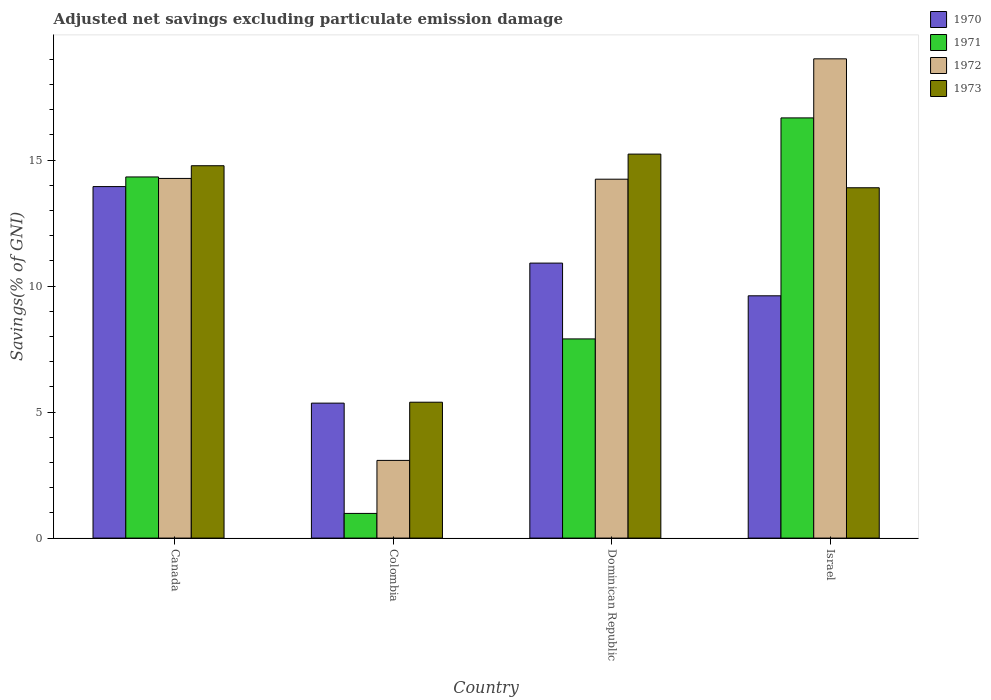What is the adjusted net savings in 1970 in Dominican Republic?
Your response must be concise. 10.91. Across all countries, what is the maximum adjusted net savings in 1973?
Provide a succinct answer. 15.24. Across all countries, what is the minimum adjusted net savings in 1973?
Your answer should be very brief. 5.39. In which country was the adjusted net savings in 1973 minimum?
Offer a terse response. Colombia. What is the total adjusted net savings in 1973 in the graph?
Offer a terse response. 49.31. What is the difference between the adjusted net savings in 1973 in Canada and that in Dominican Republic?
Make the answer very short. -0.46. What is the difference between the adjusted net savings in 1972 in Israel and the adjusted net savings in 1971 in Dominican Republic?
Keep it short and to the point. 11.11. What is the average adjusted net savings in 1970 per country?
Offer a terse response. 9.96. What is the difference between the adjusted net savings of/in 1973 and adjusted net savings of/in 1972 in Colombia?
Ensure brevity in your answer.  2.31. What is the ratio of the adjusted net savings in 1971 in Dominican Republic to that in Israel?
Your response must be concise. 0.47. Is the adjusted net savings in 1970 in Canada less than that in Dominican Republic?
Keep it short and to the point. No. What is the difference between the highest and the second highest adjusted net savings in 1971?
Keep it short and to the point. 2.34. What is the difference between the highest and the lowest adjusted net savings in 1970?
Provide a short and direct response. 8.59. Is it the case that in every country, the sum of the adjusted net savings in 1973 and adjusted net savings in 1972 is greater than the adjusted net savings in 1971?
Offer a terse response. Yes. How many bars are there?
Offer a terse response. 16. Are all the bars in the graph horizontal?
Make the answer very short. No. How many countries are there in the graph?
Offer a terse response. 4. Are the values on the major ticks of Y-axis written in scientific E-notation?
Offer a very short reply. No. Where does the legend appear in the graph?
Provide a succinct answer. Top right. How are the legend labels stacked?
Your response must be concise. Vertical. What is the title of the graph?
Your response must be concise. Adjusted net savings excluding particulate emission damage. What is the label or title of the Y-axis?
Your answer should be very brief. Savings(% of GNI). What is the Savings(% of GNI) in 1970 in Canada?
Give a very brief answer. 13.95. What is the Savings(% of GNI) in 1971 in Canada?
Your answer should be compact. 14.33. What is the Savings(% of GNI) of 1972 in Canada?
Your answer should be compact. 14.27. What is the Savings(% of GNI) in 1973 in Canada?
Offer a very short reply. 14.78. What is the Savings(% of GNI) of 1970 in Colombia?
Ensure brevity in your answer.  5.36. What is the Savings(% of GNI) of 1971 in Colombia?
Give a very brief answer. 0.98. What is the Savings(% of GNI) in 1972 in Colombia?
Offer a terse response. 3.08. What is the Savings(% of GNI) in 1973 in Colombia?
Offer a very short reply. 5.39. What is the Savings(% of GNI) of 1970 in Dominican Republic?
Your answer should be very brief. 10.91. What is the Savings(% of GNI) of 1971 in Dominican Republic?
Make the answer very short. 7.9. What is the Savings(% of GNI) of 1972 in Dominican Republic?
Your answer should be compact. 14.24. What is the Savings(% of GNI) of 1973 in Dominican Republic?
Your response must be concise. 15.24. What is the Savings(% of GNI) in 1970 in Israel?
Offer a very short reply. 9.61. What is the Savings(% of GNI) in 1971 in Israel?
Offer a terse response. 16.67. What is the Savings(% of GNI) of 1972 in Israel?
Offer a very short reply. 19.02. What is the Savings(% of GNI) of 1973 in Israel?
Your answer should be very brief. 13.9. Across all countries, what is the maximum Savings(% of GNI) of 1970?
Keep it short and to the point. 13.95. Across all countries, what is the maximum Savings(% of GNI) of 1971?
Offer a terse response. 16.67. Across all countries, what is the maximum Savings(% of GNI) of 1972?
Give a very brief answer. 19.02. Across all countries, what is the maximum Savings(% of GNI) of 1973?
Your answer should be compact. 15.24. Across all countries, what is the minimum Savings(% of GNI) in 1970?
Make the answer very short. 5.36. Across all countries, what is the minimum Savings(% of GNI) of 1971?
Offer a terse response. 0.98. Across all countries, what is the minimum Savings(% of GNI) of 1972?
Provide a short and direct response. 3.08. Across all countries, what is the minimum Savings(% of GNI) of 1973?
Give a very brief answer. 5.39. What is the total Savings(% of GNI) of 1970 in the graph?
Make the answer very short. 39.83. What is the total Savings(% of GNI) in 1971 in the graph?
Ensure brevity in your answer.  39.89. What is the total Savings(% of GNI) in 1972 in the graph?
Give a very brief answer. 50.62. What is the total Savings(% of GNI) of 1973 in the graph?
Offer a terse response. 49.31. What is the difference between the Savings(% of GNI) of 1970 in Canada and that in Colombia?
Offer a very short reply. 8.59. What is the difference between the Savings(% of GNI) of 1971 in Canada and that in Colombia?
Offer a terse response. 13.35. What is the difference between the Savings(% of GNI) in 1972 in Canada and that in Colombia?
Keep it short and to the point. 11.19. What is the difference between the Savings(% of GNI) in 1973 in Canada and that in Colombia?
Your response must be concise. 9.38. What is the difference between the Savings(% of GNI) of 1970 in Canada and that in Dominican Republic?
Keep it short and to the point. 3.04. What is the difference between the Savings(% of GNI) in 1971 in Canada and that in Dominican Republic?
Provide a succinct answer. 6.43. What is the difference between the Savings(% of GNI) in 1972 in Canada and that in Dominican Republic?
Keep it short and to the point. 0.03. What is the difference between the Savings(% of GNI) in 1973 in Canada and that in Dominican Republic?
Ensure brevity in your answer.  -0.46. What is the difference between the Savings(% of GNI) in 1970 in Canada and that in Israel?
Ensure brevity in your answer.  4.33. What is the difference between the Savings(% of GNI) in 1971 in Canada and that in Israel?
Keep it short and to the point. -2.34. What is the difference between the Savings(% of GNI) in 1972 in Canada and that in Israel?
Provide a short and direct response. -4.75. What is the difference between the Savings(% of GNI) in 1973 in Canada and that in Israel?
Ensure brevity in your answer.  0.87. What is the difference between the Savings(% of GNI) in 1970 in Colombia and that in Dominican Republic?
Provide a short and direct response. -5.56. What is the difference between the Savings(% of GNI) of 1971 in Colombia and that in Dominican Republic?
Ensure brevity in your answer.  -6.92. What is the difference between the Savings(% of GNI) of 1972 in Colombia and that in Dominican Republic?
Keep it short and to the point. -11.16. What is the difference between the Savings(% of GNI) in 1973 in Colombia and that in Dominican Republic?
Offer a terse response. -9.85. What is the difference between the Savings(% of GNI) of 1970 in Colombia and that in Israel?
Ensure brevity in your answer.  -4.26. What is the difference between the Savings(% of GNI) in 1971 in Colombia and that in Israel?
Ensure brevity in your answer.  -15.7. What is the difference between the Savings(% of GNI) in 1972 in Colombia and that in Israel?
Provide a short and direct response. -15.94. What is the difference between the Savings(% of GNI) in 1973 in Colombia and that in Israel?
Make the answer very short. -8.51. What is the difference between the Savings(% of GNI) in 1970 in Dominican Republic and that in Israel?
Your response must be concise. 1.3. What is the difference between the Savings(% of GNI) of 1971 in Dominican Republic and that in Israel?
Provide a succinct answer. -8.77. What is the difference between the Savings(% of GNI) of 1972 in Dominican Republic and that in Israel?
Provide a succinct answer. -4.78. What is the difference between the Savings(% of GNI) in 1973 in Dominican Republic and that in Israel?
Provide a succinct answer. 1.34. What is the difference between the Savings(% of GNI) of 1970 in Canada and the Savings(% of GNI) of 1971 in Colombia?
Offer a very short reply. 12.97. What is the difference between the Savings(% of GNI) of 1970 in Canada and the Savings(% of GNI) of 1972 in Colombia?
Offer a terse response. 10.87. What is the difference between the Savings(% of GNI) in 1970 in Canada and the Savings(% of GNI) in 1973 in Colombia?
Your answer should be compact. 8.56. What is the difference between the Savings(% of GNI) in 1971 in Canada and the Savings(% of GNI) in 1972 in Colombia?
Give a very brief answer. 11.25. What is the difference between the Savings(% of GNI) of 1971 in Canada and the Savings(% of GNI) of 1973 in Colombia?
Offer a terse response. 8.94. What is the difference between the Savings(% of GNI) of 1972 in Canada and the Savings(% of GNI) of 1973 in Colombia?
Ensure brevity in your answer.  8.88. What is the difference between the Savings(% of GNI) in 1970 in Canada and the Savings(% of GNI) in 1971 in Dominican Republic?
Provide a short and direct response. 6.05. What is the difference between the Savings(% of GNI) of 1970 in Canada and the Savings(% of GNI) of 1972 in Dominican Republic?
Your answer should be very brief. -0.29. What is the difference between the Savings(% of GNI) of 1970 in Canada and the Savings(% of GNI) of 1973 in Dominican Republic?
Your response must be concise. -1.29. What is the difference between the Savings(% of GNI) in 1971 in Canada and the Savings(% of GNI) in 1972 in Dominican Republic?
Your response must be concise. 0.09. What is the difference between the Savings(% of GNI) of 1971 in Canada and the Savings(% of GNI) of 1973 in Dominican Republic?
Make the answer very short. -0.91. What is the difference between the Savings(% of GNI) in 1972 in Canada and the Savings(% of GNI) in 1973 in Dominican Republic?
Your answer should be compact. -0.97. What is the difference between the Savings(% of GNI) in 1970 in Canada and the Savings(% of GNI) in 1971 in Israel?
Offer a terse response. -2.73. What is the difference between the Savings(% of GNI) in 1970 in Canada and the Savings(% of GNI) in 1972 in Israel?
Your answer should be very brief. -5.07. What is the difference between the Savings(% of GNI) of 1970 in Canada and the Savings(% of GNI) of 1973 in Israel?
Keep it short and to the point. 0.05. What is the difference between the Savings(% of GNI) of 1971 in Canada and the Savings(% of GNI) of 1972 in Israel?
Give a very brief answer. -4.69. What is the difference between the Savings(% of GNI) of 1971 in Canada and the Savings(% of GNI) of 1973 in Israel?
Provide a short and direct response. 0.43. What is the difference between the Savings(% of GNI) in 1972 in Canada and the Savings(% of GNI) in 1973 in Israel?
Your answer should be compact. 0.37. What is the difference between the Savings(% of GNI) of 1970 in Colombia and the Savings(% of GNI) of 1971 in Dominican Republic?
Ensure brevity in your answer.  -2.55. What is the difference between the Savings(% of GNI) of 1970 in Colombia and the Savings(% of GNI) of 1972 in Dominican Republic?
Ensure brevity in your answer.  -8.89. What is the difference between the Savings(% of GNI) of 1970 in Colombia and the Savings(% of GNI) of 1973 in Dominican Republic?
Ensure brevity in your answer.  -9.88. What is the difference between the Savings(% of GNI) in 1971 in Colombia and the Savings(% of GNI) in 1972 in Dominican Republic?
Keep it short and to the point. -13.26. What is the difference between the Savings(% of GNI) in 1971 in Colombia and the Savings(% of GNI) in 1973 in Dominican Republic?
Keep it short and to the point. -14.26. What is the difference between the Savings(% of GNI) in 1972 in Colombia and the Savings(% of GNI) in 1973 in Dominican Republic?
Offer a very short reply. -12.15. What is the difference between the Savings(% of GNI) in 1970 in Colombia and the Savings(% of GNI) in 1971 in Israel?
Ensure brevity in your answer.  -11.32. What is the difference between the Savings(% of GNI) in 1970 in Colombia and the Savings(% of GNI) in 1972 in Israel?
Provide a succinct answer. -13.66. What is the difference between the Savings(% of GNI) of 1970 in Colombia and the Savings(% of GNI) of 1973 in Israel?
Your answer should be very brief. -8.55. What is the difference between the Savings(% of GNI) of 1971 in Colombia and the Savings(% of GNI) of 1972 in Israel?
Provide a succinct answer. -18.04. What is the difference between the Savings(% of GNI) of 1971 in Colombia and the Savings(% of GNI) of 1973 in Israel?
Provide a succinct answer. -12.92. What is the difference between the Savings(% of GNI) of 1972 in Colombia and the Savings(% of GNI) of 1973 in Israel?
Your response must be concise. -10.82. What is the difference between the Savings(% of GNI) of 1970 in Dominican Republic and the Savings(% of GNI) of 1971 in Israel?
Offer a terse response. -5.76. What is the difference between the Savings(% of GNI) of 1970 in Dominican Republic and the Savings(% of GNI) of 1972 in Israel?
Ensure brevity in your answer.  -8.11. What is the difference between the Savings(% of GNI) of 1970 in Dominican Republic and the Savings(% of GNI) of 1973 in Israel?
Your answer should be compact. -2.99. What is the difference between the Savings(% of GNI) of 1971 in Dominican Republic and the Savings(% of GNI) of 1972 in Israel?
Keep it short and to the point. -11.11. What is the difference between the Savings(% of GNI) of 1971 in Dominican Republic and the Savings(% of GNI) of 1973 in Israel?
Offer a very short reply. -6. What is the difference between the Savings(% of GNI) of 1972 in Dominican Republic and the Savings(% of GNI) of 1973 in Israel?
Keep it short and to the point. 0.34. What is the average Savings(% of GNI) in 1970 per country?
Offer a terse response. 9.96. What is the average Savings(% of GNI) in 1971 per country?
Your answer should be compact. 9.97. What is the average Savings(% of GNI) in 1972 per country?
Offer a terse response. 12.65. What is the average Savings(% of GNI) in 1973 per country?
Provide a succinct answer. 12.33. What is the difference between the Savings(% of GNI) in 1970 and Savings(% of GNI) in 1971 in Canada?
Your response must be concise. -0.38. What is the difference between the Savings(% of GNI) in 1970 and Savings(% of GNI) in 1972 in Canada?
Provide a short and direct response. -0.32. What is the difference between the Savings(% of GNI) of 1970 and Savings(% of GNI) of 1973 in Canada?
Provide a short and direct response. -0.83. What is the difference between the Savings(% of GNI) of 1971 and Savings(% of GNI) of 1972 in Canada?
Your answer should be compact. 0.06. What is the difference between the Savings(% of GNI) of 1971 and Savings(% of GNI) of 1973 in Canada?
Make the answer very short. -0.45. What is the difference between the Savings(% of GNI) in 1972 and Savings(% of GNI) in 1973 in Canada?
Your answer should be very brief. -0.5. What is the difference between the Savings(% of GNI) of 1970 and Savings(% of GNI) of 1971 in Colombia?
Offer a very short reply. 4.38. What is the difference between the Savings(% of GNI) of 1970 and Savings(% of GNI) of 1972 in Colombia?
Ensure brevity in your answer.  2.27. What is the difference between the Savings(% of GNI) of 1970 and Savings(% of GNI) of 1973 in Colombia?
Make the answer very short. -0.04. What is the difference between the Savings(% of GNI) in 1971 and Savings(% of GNI) in 1972 in Colombia?
Provide a succinct answer. -2.1. What is the difference between the Savings(% of GNI) of 1971 and Savings(% of GNI) of 1973 in Colombia?
Keep it short and to the point. -4.41. What is the difference between the Savings(% of GNI) in 1972 and Savings(% of GNI) in 1973 in Colombia?
Provide a succinct answer. -2.31. What is the difference between the Savings(% of GNI) in 1970 and Savings(% of GNI) in 1971 in Dominican Republic?
Offer a very short reply. 3.01. What is the difference between the Savings(% of GNI) of 1970 and Savings(% of GNI) of 1972 in Dominican Republic?
Give a very brief answer. -3.33. What is the difference between the Savings(% of GNI) in 1970 and Savings(% of GNI) in 1973 in Dominican Republic?
Offer a terse response. -4.33. What is the difference between the Savings(% of GNI) of 1971 and Savings(% of GNI) of 1972 in Dominican Republic?
Keep it short and to the point. -6.34. What is the difference between the Savings(% of GNI) in 1971 and Savings(% of GNI) in 1973 in Dominican Republic?
Ensure brevity in your answer.  -7.33. What is the difference between the Savings(% of GNI) in 1972 and Savings(% of GNI) in 1973 in Dominican Republic?
Offer a very short reply. -1. What is the difference between the Savings(% of GNI) of 1970 and Savings(% of GNI) of 1971 in Israel?
Your answer should be very brief. -7.06. What is the difference between the Savings(% of GNI) of 1970 and Savings(% of GNI) of 1972 in Israel?
Your answer should be compact. -9.4. What is the difference between the Savings(% of GNI) of 1970 and Savings(% of GNI) of 1973 in Israel?
Keep it short and to the point. -4.29. What is the difference between the Savings(% of GNI) of 1971 and Savings(% of GNI) of 1972 in Israel?
Offer a very short reply. -2.34. What is the difference between the Savings(% of GNI) of 1971 and Savings(% of GNI) of 1973 in Israel?
Ensure brevity in your answer.  2.77. What is the difference between the Savings(% of GNI) in 1972 and Savings(% of GNI) in 1973 in Israel?
Ensure brevity in your answer.  5.12. What is the ratio of the Savings(% of GNI) in 1970 in Canada to that in Colombia?
Your answer should be compact. 2.6. What is the ratio of the Savings(% of GNI) of 1971 in Canada to that in Colombia?
Keep it short and to the point. 14.64. What is the ratio of the Savings(% of GNI) in 1972 in Canada to that in Colombia?
Your response must be concise. 4.63. What is the ratio of the Savings(% of GNI) in 1973 in Canada to that in Colombia?
Provide a short and direct response. 2.74. What is the ratio of the Savings(% of GNI) in 1970 in Canada to that in Dominican Republic?
Offer a very short reply. 1.28. What is the ratio of the Savings(% of GNI) of 1971 in Canada to that in Dominican Republic?
Your answer should be compact. 1.81. What is the ratio of the Savings(% of GNI) in 1973 in Canada to that in Dominican Republic?
Ensure brevity in your answer.  0.97. What is the ratio of the Savings(% of GNI) of 1970 in Canada to that in Israel?
Your response must be concise. 1.45. What is the ratio of the Savings(% of GNI) of 1971 in Canada to that in Israel?
Your answer should be very brief. 0.86. What is the ratio of the Savings(% of GNI) of 1972 in Canada to that in Israel?
Keep it short and to the point. 0.75. What is the ratio of the Savings(% of GNI) in 1973 in Canada to that in Israel?
Offer a very short reply. 1.06. What is the ratio of the Savings(% of GNI) of 1970 in Colombia to that in Dominican Republic?
Keep it short and to the point. 0.49. What is the ratio of the Savings(% of GNI) of 1971 in Colombia to that in Dominican Republic?
Provide a short and direct response. 0.12. What is the ratio of the Savings(% of GNI) of 1972 in Colombia to that in Dominican Republic?
Give a very brief answer. 0.22. What is the ratio of the Savings(% of GNI) in 1973 in Colombia to that in Dominican Republic?
Provide a succinct answer. 0.35. What is the ratio of the Savings(% of GNI) of 1970 in Colombia to that in Israel?
Ensure brevity in your answer.  0.56. What is the ratio of the Savings(% of GNI) of 1971 in Colombia to that in Israel?
Your response must be concise. 0.06. What is the ratio of the Savings(% of GNI) of 1972 in Colombia to that in Israel?
Your response must be concise. 0.16. What is the ratio of the Savings(% of GNI) in 1973 in Colombia to that in Israel?
Ensure brevity in your answer.  0.39. What is the ratio of the Savings(% of GNI) in 1970 in Dominican Republic to that in Israel?
Offer a very short reply. 1.14. What is the ratio of the Savings(% of GNI) of 1971 in Dominican Republic to that in Israel?
Keep it short and to the point. 0.47. What is the ratio of the Savings(% of GNI) in 1972 in Dominican Republic to that in Israel?
Your answer should be very brief. 0.75. What is the ratio of the Savings(% of GNI) in 1973 in Dominican Republic to that in Israel?
Your response must be concise. 1.1. What is the difference between the highest and the second highest Savings(% of GNI) of 1970?
Your answer should be compact. 3.04. What is the difference between the highest and the second highest Savings(% of GNI) in 1971?
Ensure brevity in your answer.  2.34. What is the difference between the highest and the second highest Savings(% of GNI) in 1972?
Offer a very short reply. 4.75. What is the difference between the highest and the second highest Savings(% of GNI) in 1973?
Keep it short and to the point. 0.46. What is the difference between the highest and the lowest Savings(% of GNI) in 1970?
Your answer should be very brief. 8.59. What is the difference between the highest and the lowest Savings(% of GNI) of 1971?
Provide a short and direct response. 15.7. What is the difference between the highest and the lowest Savings(% of GNI) in 1972?
Give a very brief answer. 15.94. What is the difference between the highest and the lowest Savings(% of GNI) of 1973?
Provide a short and direct response. 9.85. 